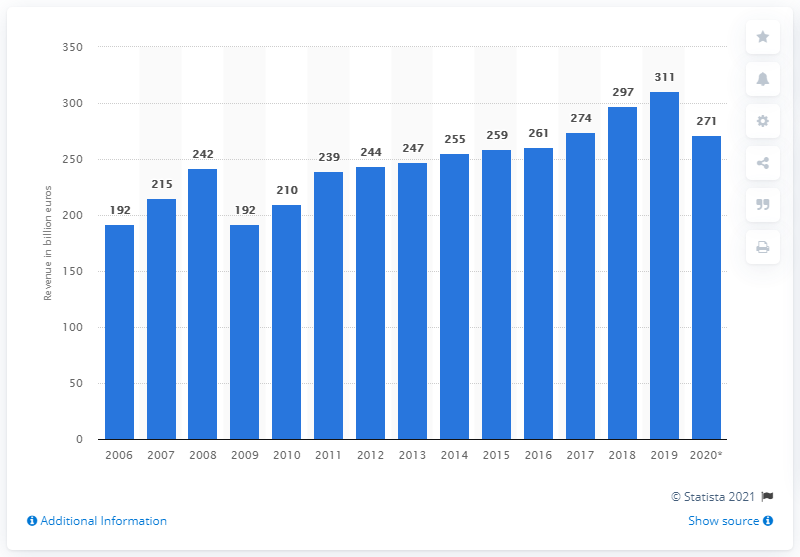Draw attention to some important aspects in this diagram. In 2020, the mechanical engineering industry in Germany generated a revenue of 271... 